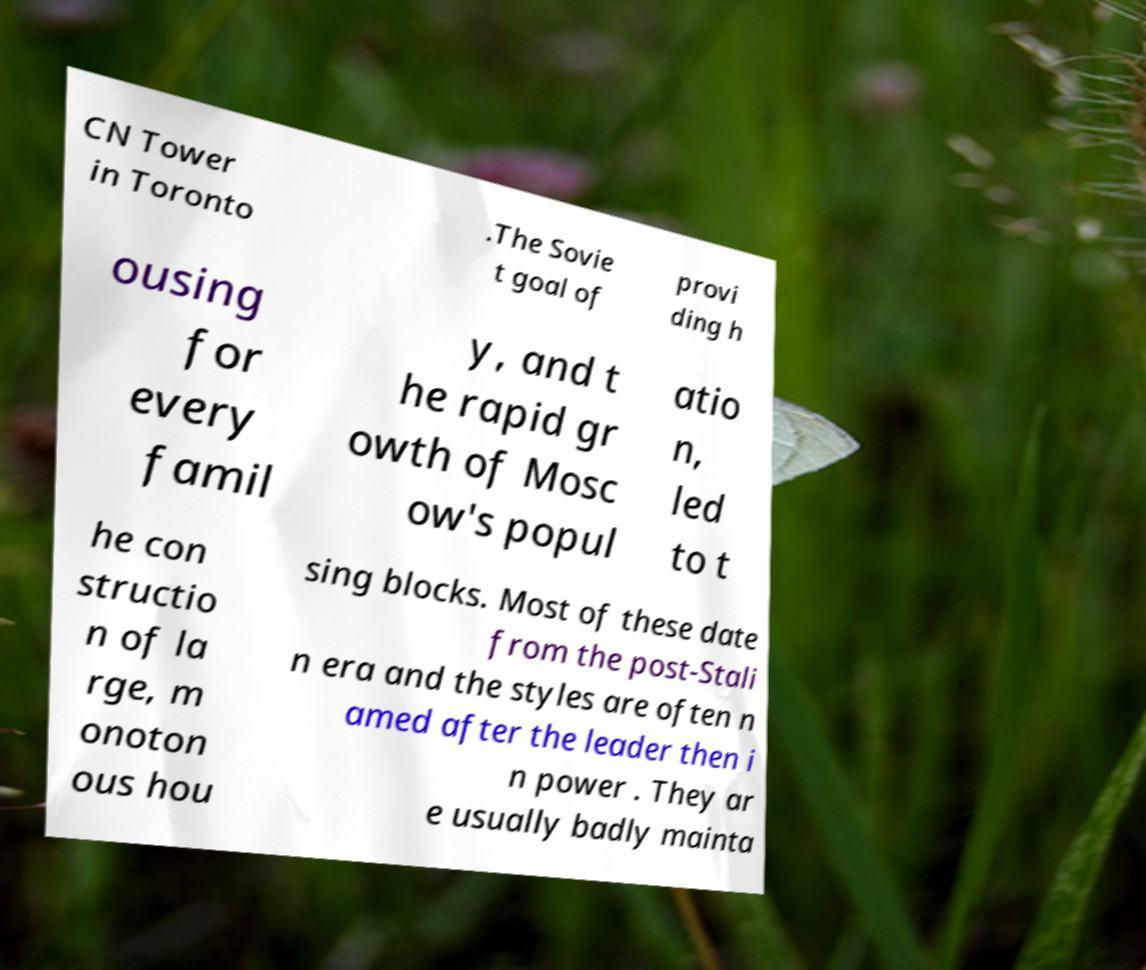For documentation purposes, I need the text within this image transcribed. Could you provide that? CN Tower in Toronto .The Sovie t goal of provi ding h ousing for every famil y, and t he rapid gr owth of Mosc ow's popul atio n, led to t he con structio n of la rge, m onoton ous hou sing blocks. Most of these date from the post-Stali n era and the styles are often n amed after the leader then i n power . They ar e usually badly mainta 